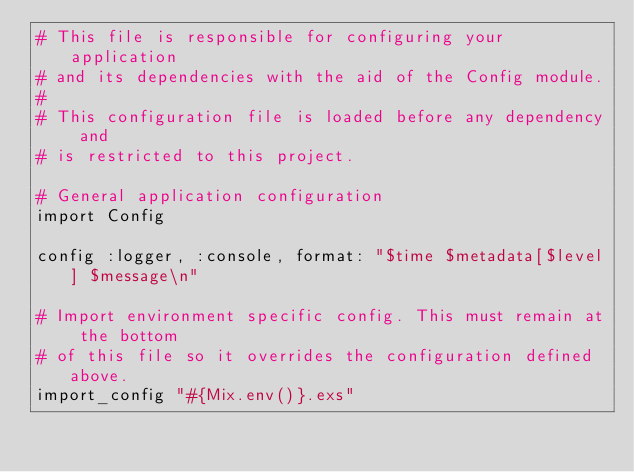<code> <loc_0><loc_0><loc_500><loc_500><_Elixir_># This file is responsible for configuring your application
# and its dependencies with the aid of the Config module.
#
# This configuration file is loaded before any dependency and
# is restricted to this project.

# General application configuration
import Config

config :logger, :console, format: "$time $metadata[$level] $message\n"

# Import environment specific config. This must remain at the bottom
# of this file so it overrides the configuration defined above.
import_config "#{Mix.env()}.exs"
</code> 